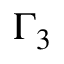<formula> <loc_0><loc_0><loc_500><loc_500>\Gamma _ { 3 }</formula> 